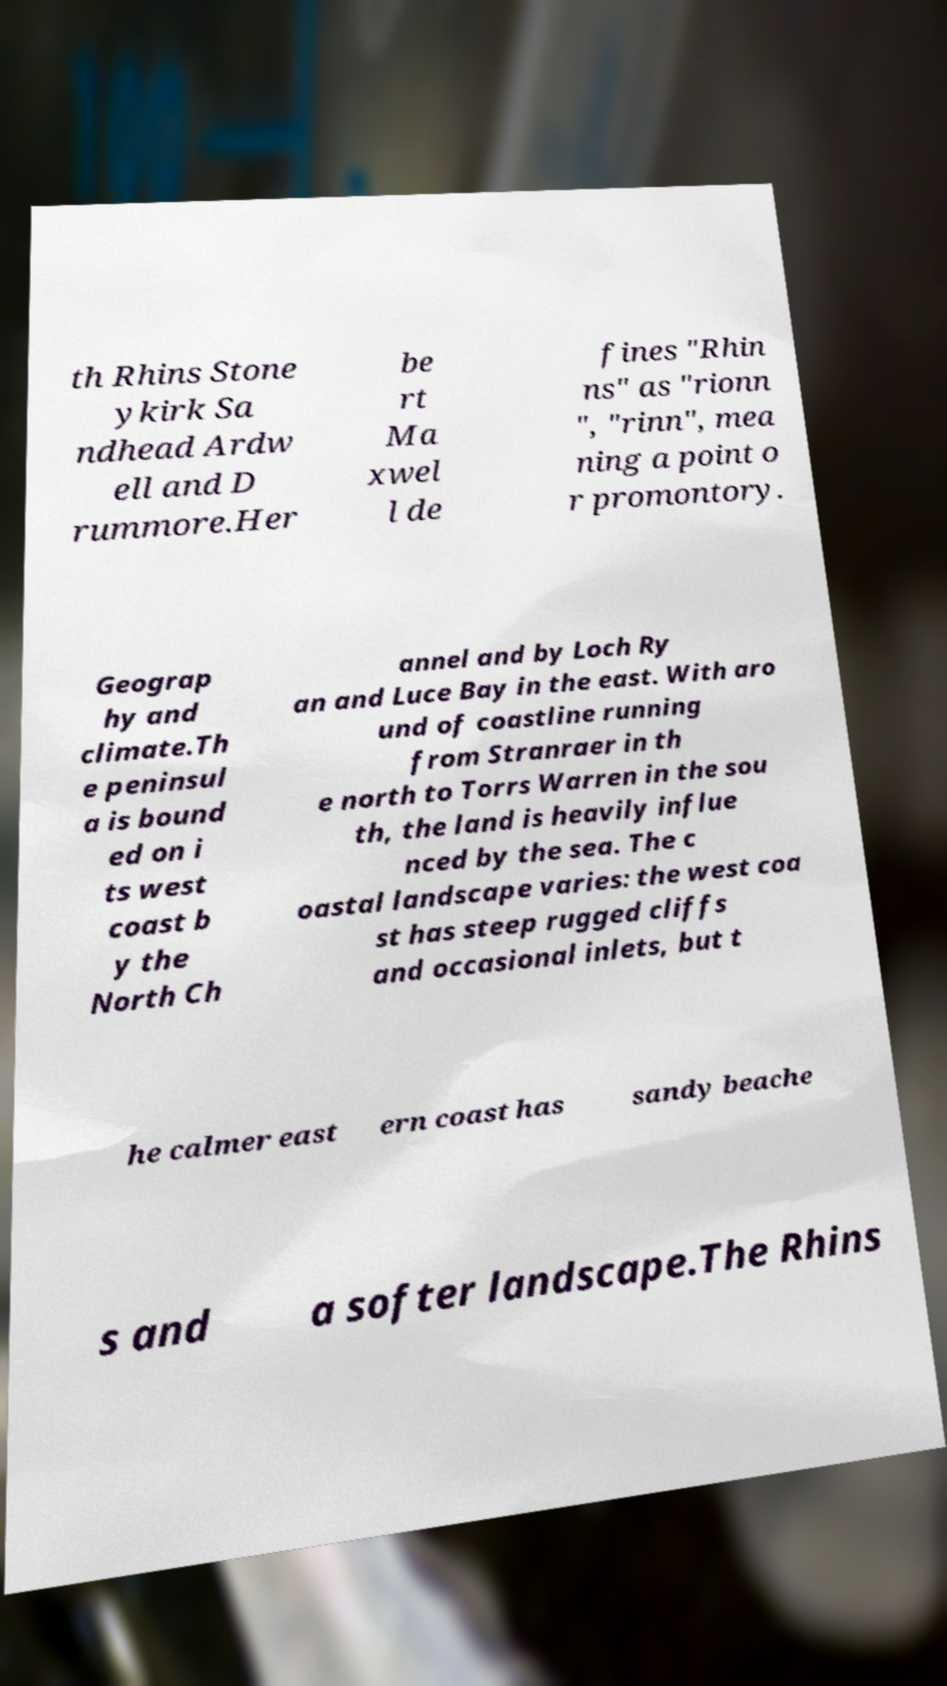There's text embedded in this image that I need extracted. Can you transcribe it verbatim? th Rhins Stone ykirk Sa ndhead Ardw ell and D rummore.Her be rt Ma xwel l de fines "Rhin ns" as "rionn ", "rinn", mea ning a point o r promontory. Geograp hy and climate.Th e peninsul a is bound ed on i ts west coast b y the North Ch annel and by Loch Ry an and Luce Bay in the east. With aro und of coastline running from Stranraer in th e north to Torrs Warren in the sou th, the land is heavily influe nced by the sea. The c oastal landscape varies: the west coa st has steep rugged cliffs and occasional inlets, but t he calmer east ern coast has sandy beache s and a softer landscape.The Rhins 